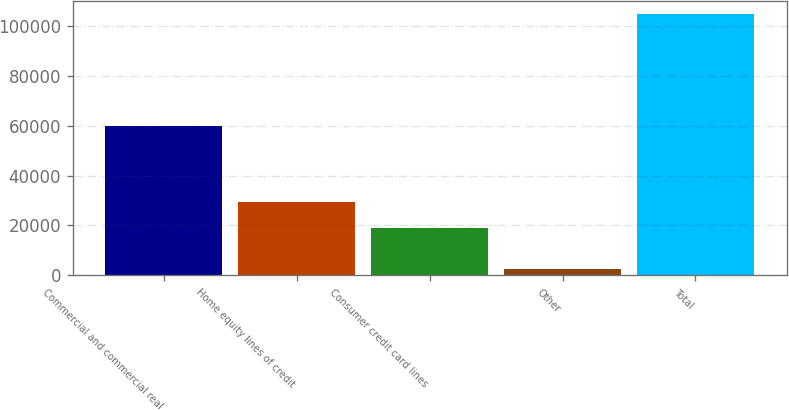<chart> <loc_0><loc_0><loc_500><loc_500><bar_chart><fcel>Commercial and commercial real<fcel>Home equity lines of credit<fcel>Consumer credit card lines<fcel>Other<fcel>Total<nl><fcel>59982<fcel>29248.5<fcel>19028<fcel>2683<fcel>104888<nl></chart> 